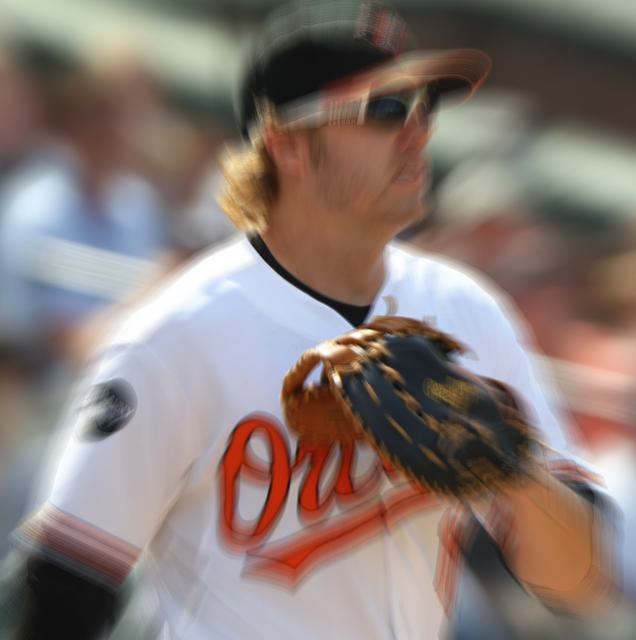Can you describe the subject's activity and attire? The subject appears to be dressed in a baseball uniform, indicative of an athlete involved in a baseball game. The uniform is predominantly white with orange and black details, which are team colors commonly associated with baseball attire. Although the image's motion blur obscures finer details, we can discern that the person is wearing a glove and likely in the middle of a play. 